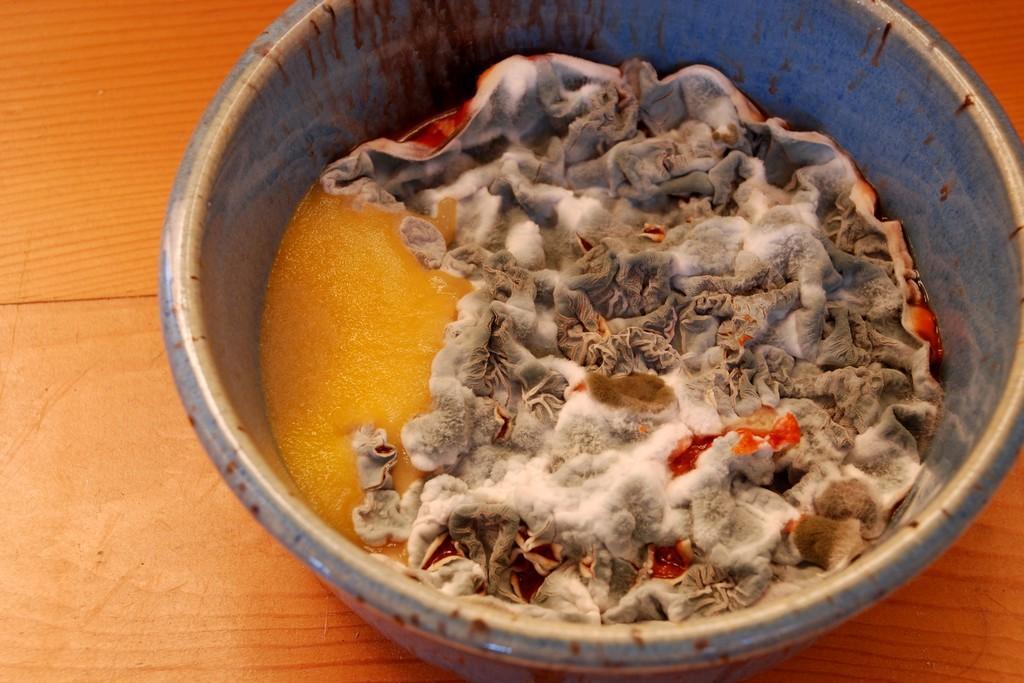Could you give a brief overview of what you see in this image? In this picture I can see a moldy food item in a bowl, which is on the wooden board. 